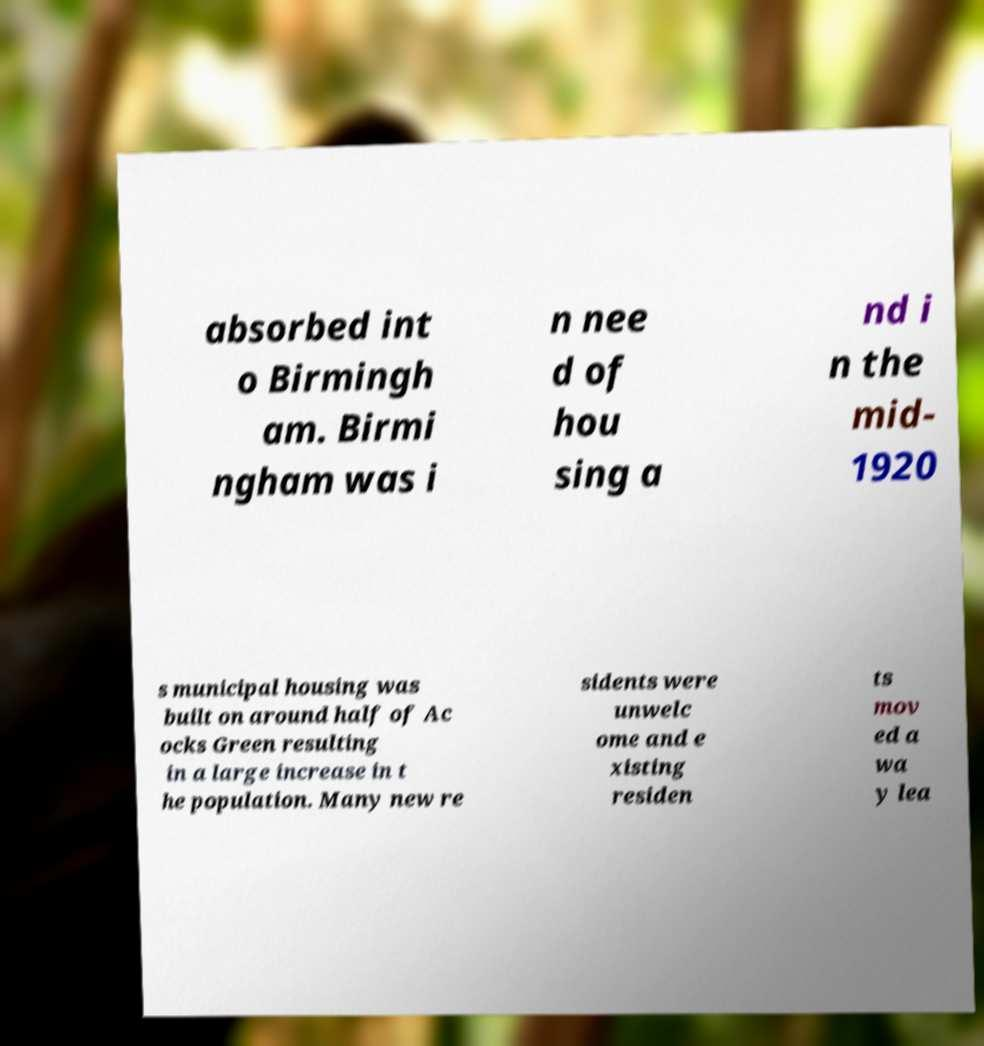Could you extract and type out the text from this image? absorbed int o Birmingh am. Birmi ngham was i n nee d of hou sing a nd i n the mid- 1920 s municipal housing was built on around half of Ac ocks Green resulting in a large increase in t he population. Many new re sidents were unwelc ome and e xisting residen ts mov ed a wa y lea 